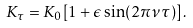Convert formula to latex. <formula><loc_0><loc_0><loc_500><loc_500>K _ { \tau } = K _ { 0 } [ 1 + \epsilon \sin ( 2 \pi \nu \tau ) ] \, .</formula> 